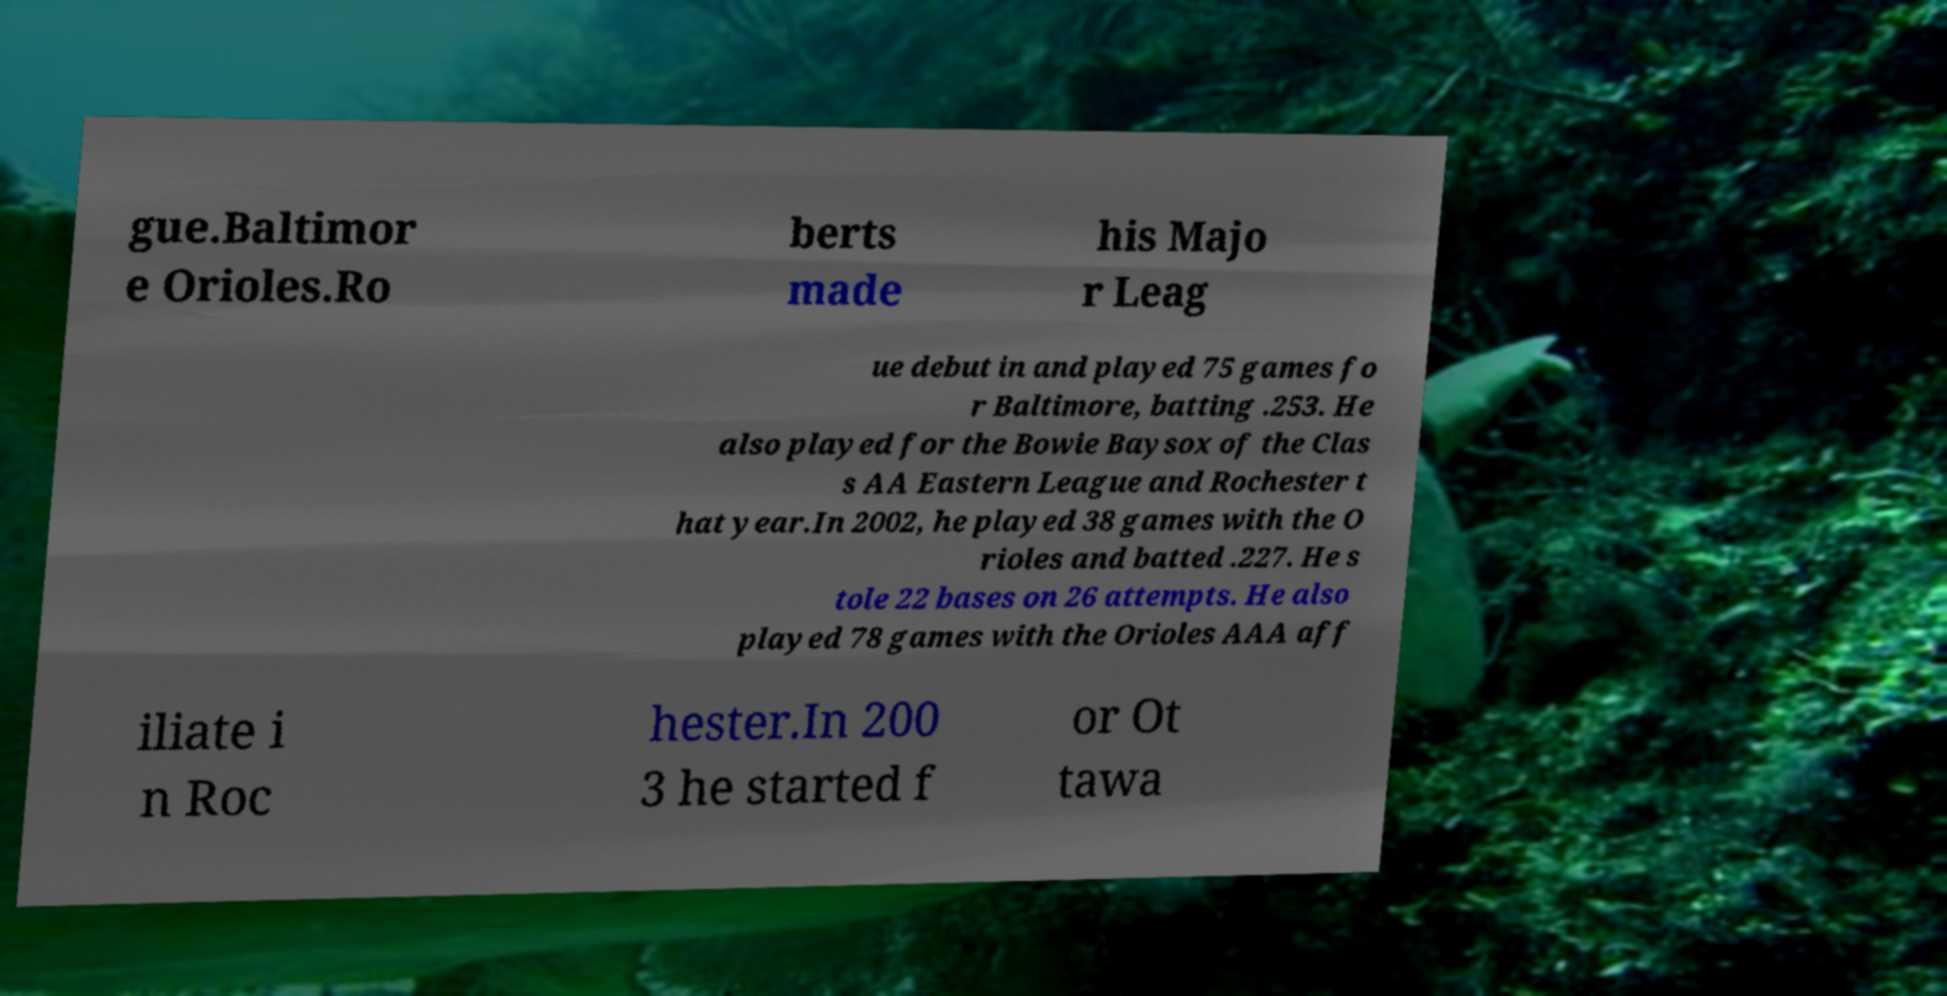Please identify and transcribe the text found in this image. gue.Baltimor e Orioles.Ro berts made his Majo r Leag ue debut in and played 75 games fo r Baltimore, batting .253. He also played for the Bowie Baysox of the Clas s AA Eastern League and Rochester t hat year.In 2002, he played 38 games with the O rioles and batted .227. He s tole 22 bases on 26 attempts. He also played 78 games with the Orioles AAA aff iliate i n Roc hester.In 200 3 he started f or Ot tawa 